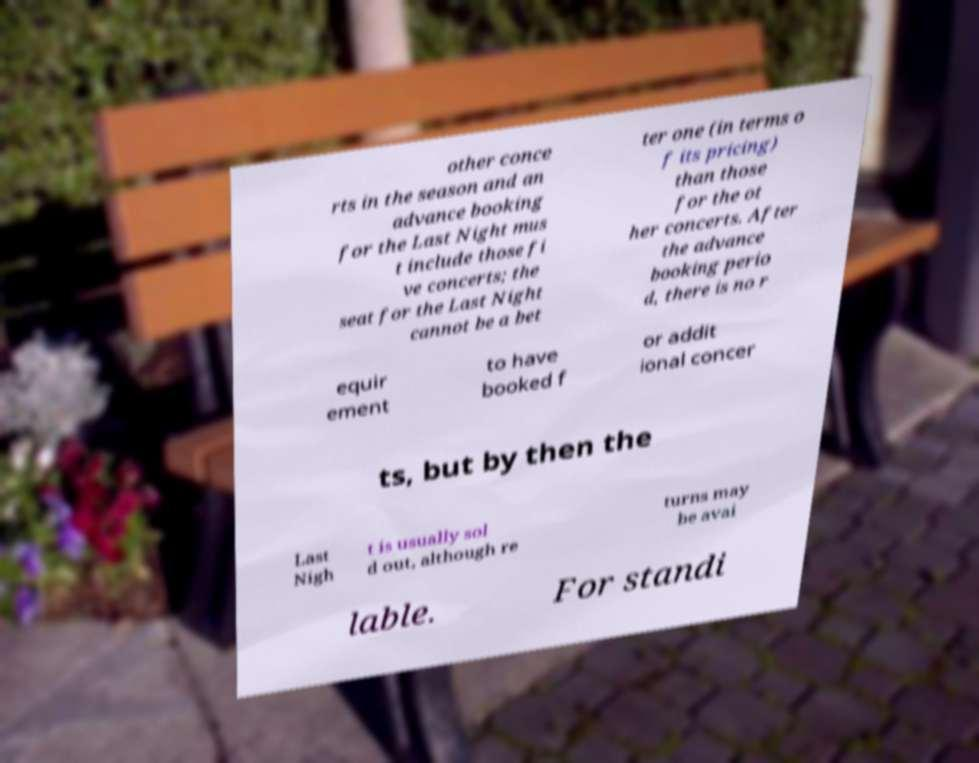Can you accurately transcribe the text from the provided image for me? other conce rts in the season and an advance booking for the Last Night mus t include those fi ve concerts; the seat for the Last Night cannot be a bet ter one (in terms o f its pricing) than those for the ot her concerts. After the advance booking perio d, there is no r equir ement to have booked f or addit ional concer ts, but by then the Last Nigh t is usually sol d out, although re turns may be avai lable. For standi 